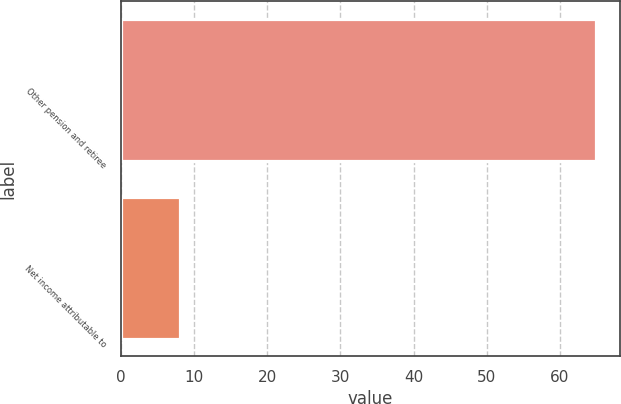<chart> <loc_0><loc_0><loc_500><loc_500><bar_chart><fcel>Other pension and retiree<fcel>Net income attributable to<nl><fcel>65<fcel>8<nl></chart> 